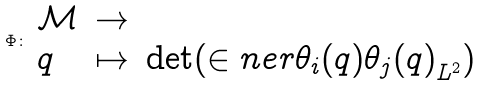<formula> <loc_0><loc_0><loc_500><loc_500>\Phi \colon \begin{array} [ t ] { l c l } \mathcal { M } & \rightarrow & \real \\ q & \mapsto & \det ( \in n e r { \theta _ { i } ( q ) } { \theta _ { j } ( q ) } _ { L ^ { 2 } } ) \end{array}</formula> 